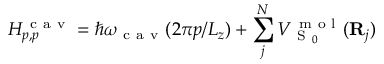<formula> <loc_0><loc_0><loc_500><loc_500>H _ { p , p } ^ { c a v } = \hslash \omega _ { c a v } ( 2 \pi p / L _ { z } ) + \sum _ { j } ^ { N } V _ { S _ { 0 } } ^ { m o l } ( { R } _ { j } )</formula> 